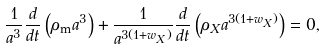Convert formula to latex. <formula><loc_0><loc_0><loc_500><loc_500>\frac { 1 } { a ^ { 3 } } \frac { d } { d t } \left ( \rho _ { \text {m} } a ^ { 3 } \right ) + \frac { 1 } { a ^ { 3 ( 1 + w _ { X } ) } } \frac { d } { d t } \left ( \rho _ { X } a ^ { 3 ( 1 + w _ { X } ) } \right ) = 0 ,</formula> 